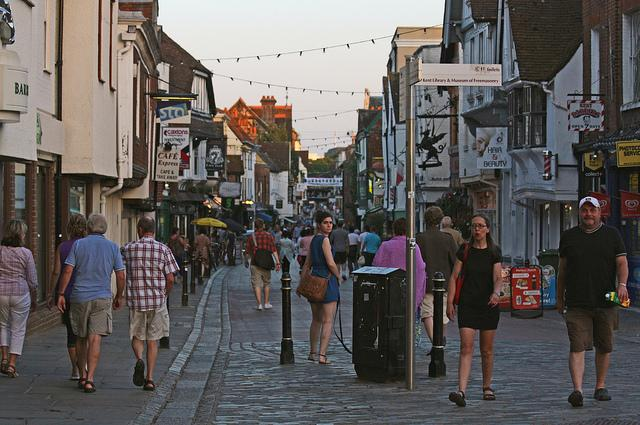What kind of area in town is this? street 